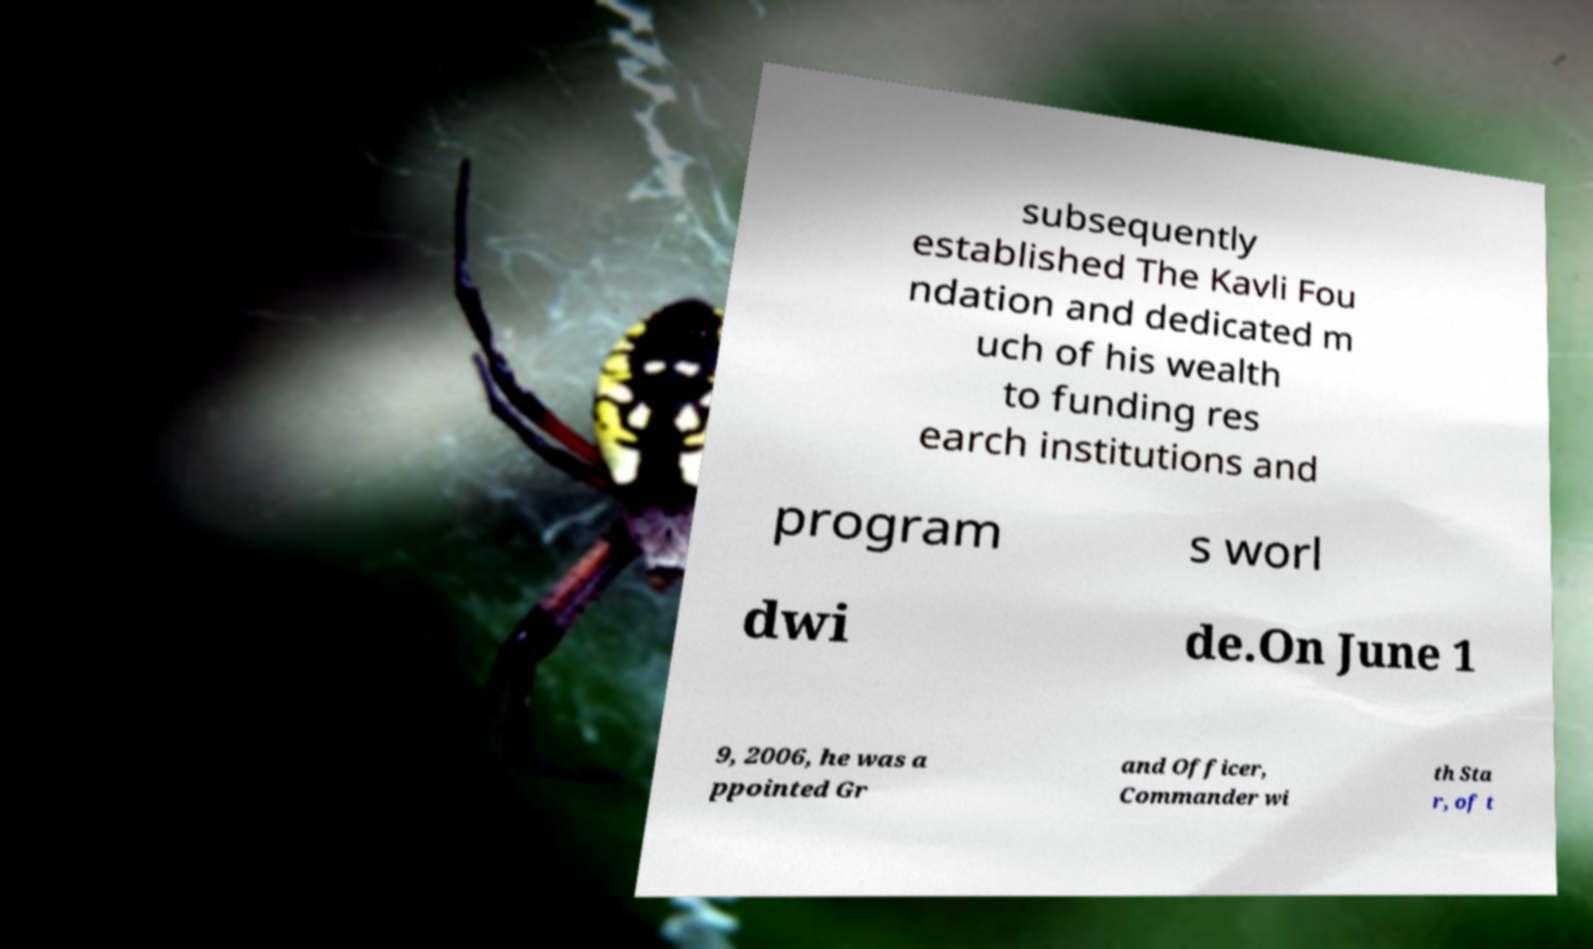What messages or text are displayed in this image? I need them in a readable, typed format. subsequently established The Kavli Fou ndation and dedicated m uch of his wealth to funding res earch institutions and program s worl dwi de.On June 1 9, 2006, he was a ppointed Gr and Officer, Commander wi th Sta r, of t 